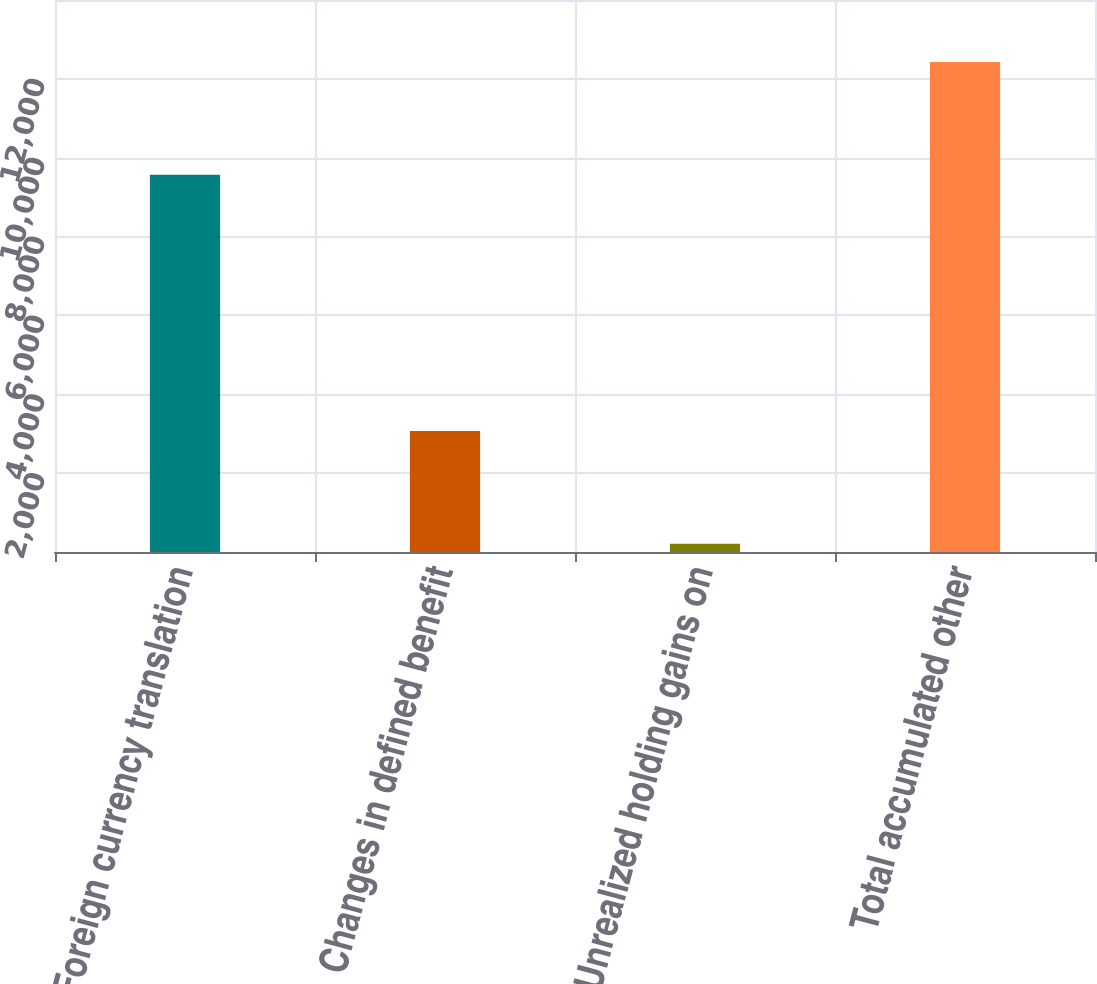<chart> <loc_0><loc_0><loc_500><loc_500><bar_chart><fcel>Foreign currency translation<fcel>Changes in defined benefit<fcel>Unrealized holding gains on<fcel>Total accumulated other<nl><fcel>9569<fcel>3066<fcel>210<fcel>12425<nl></chart> 